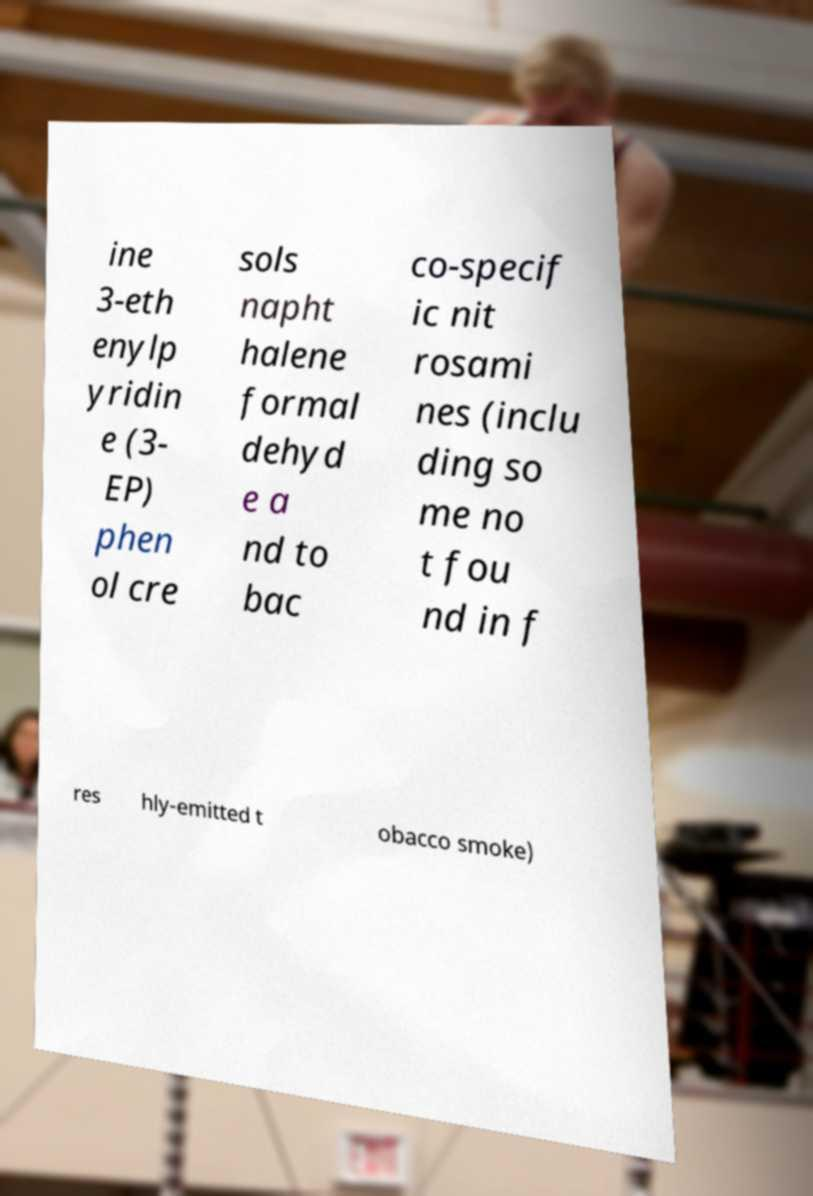Please read and relay the text visible in this image. What does it say? ine 3-eth enylp yridin e (3- EP) phen ol cre sols napht halene formal dehyd e a nd to bac co-specif ic nit rosami nes (inclu ding so me no t fou nd in f res hly-emitted t obacco smoke) 